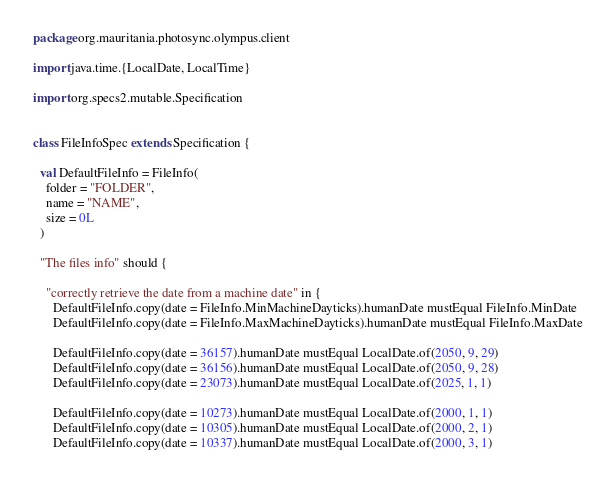<code> <loc_0><loc_0><loc_500><loc_500><_Scala_>package org.mauritania.photosync.olympus.client

import java.time.{LocalDate, LocalTime}

import org.specs2.mutable.Specification


class FileInfoSpec extends Specification {

  val DefaultFileInfo = FileInfo(
    folder = "FOLDER",
    name = "NAME",
    size = 0L
  )

  "The files info" should {

    "correctly retrieve the date from a machine date" in {
      DefaultFileInfo.copy(date = FileInfo.MinMachineDayticks).humanDate mustEqual FileInfo.MinDate
      DefaultFileInfo.copy(date = FileInfo.MaxMachineDayticks).humanDate mustEqual FileInfo.MaxDate

      DefaultFileInfo.copy(date = 36157).humanDate mustEqual LocalDate.of(2050, 9, 29)
      DefaultFileInfo.copy(date = 36156).humanDate mustEqual LocalDate.of(2050, 9, 28)
      DefaultFileInfo.copy(date = 23073).humanDate mustEqual LocalDate.of(2025, 1, 1)

      DefaultFileInfo.copy(date = 10273).humanDate mustEqual LocalDate.of(2000, 1, 1)
      DefaultFileInfo.copy(date = 10305).humanDate mustEqual LocalDate.of(2000, 2, 1)
      DefaultFileInfo.copy(date = 10337).humanDate mustEqual LocalDate.of(2000, 3, 1)</code> 